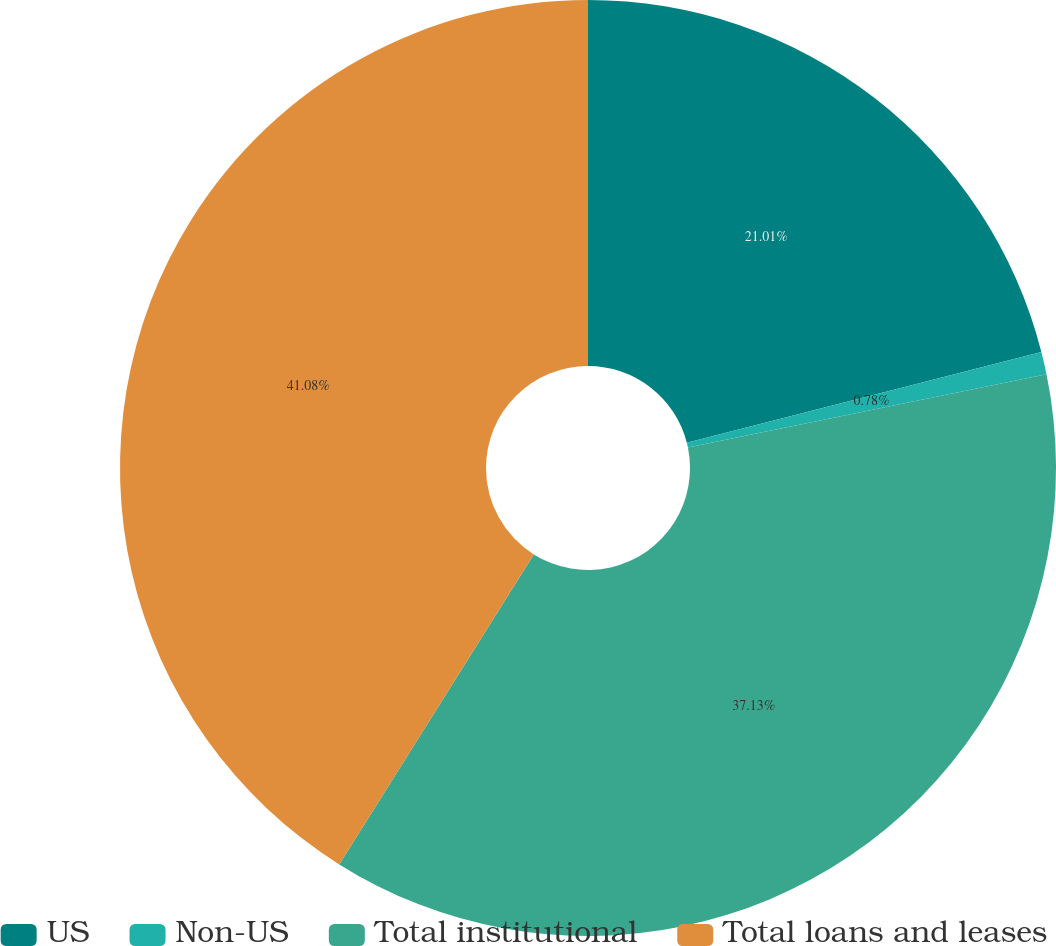Convert chart to OTSL. <chart><loc_0><loc_0><loc_500><loc_500><pie_chart><fcel>US<fcel>Non-US<fcel>Total institutional<fcel>Total loans and leases<nl><fcel>21.01%<fcel>0.78%<fcel>37.13%<fcel>41.08%<nl></chart> 